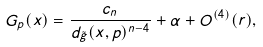Convert formula to latex. <formula><loc_0><loc_0><loc_500><loc_500>G _ { p } ( x ) = \frac { c _ { n } } { d _ { \tilde { g } } ( x , p ) ^ { n - 4 } } + \alpha + O ^ { ( 4 ) } ( r ) ,</formula> 